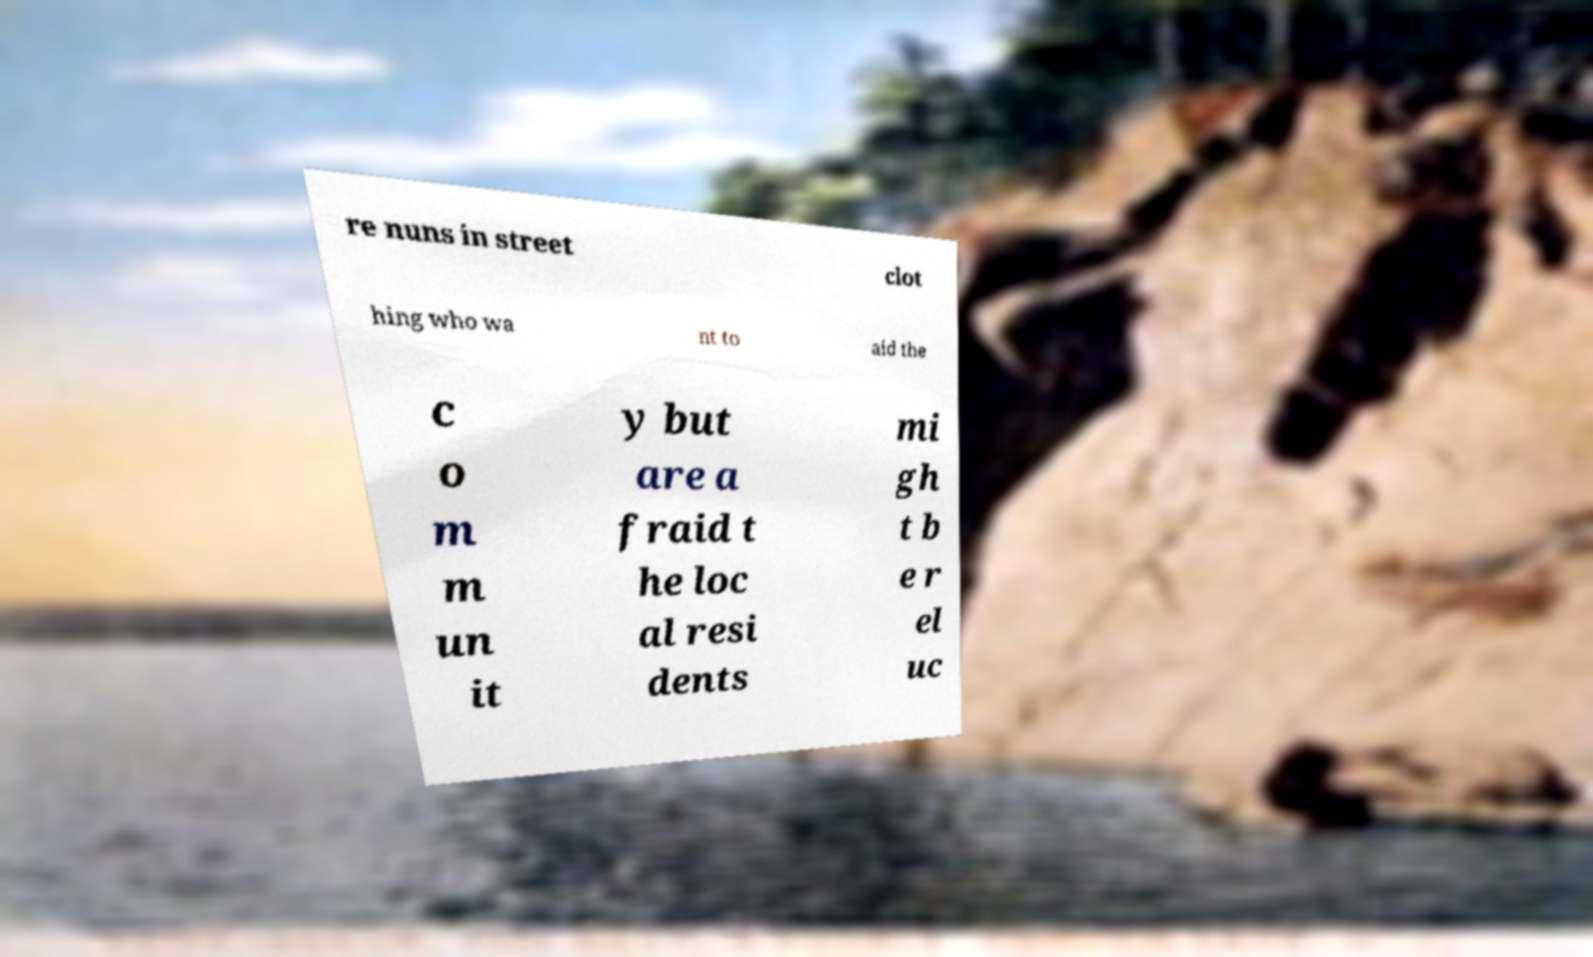Can you read and provide the text displayed in the image?This photo seems to have some interesting text. Can you extract and type it out for me? re nuns in street clot hing who wa nt to aid the c o m m un it y but are a fraid t he loc al resi dents mi gh t b e r el uc 